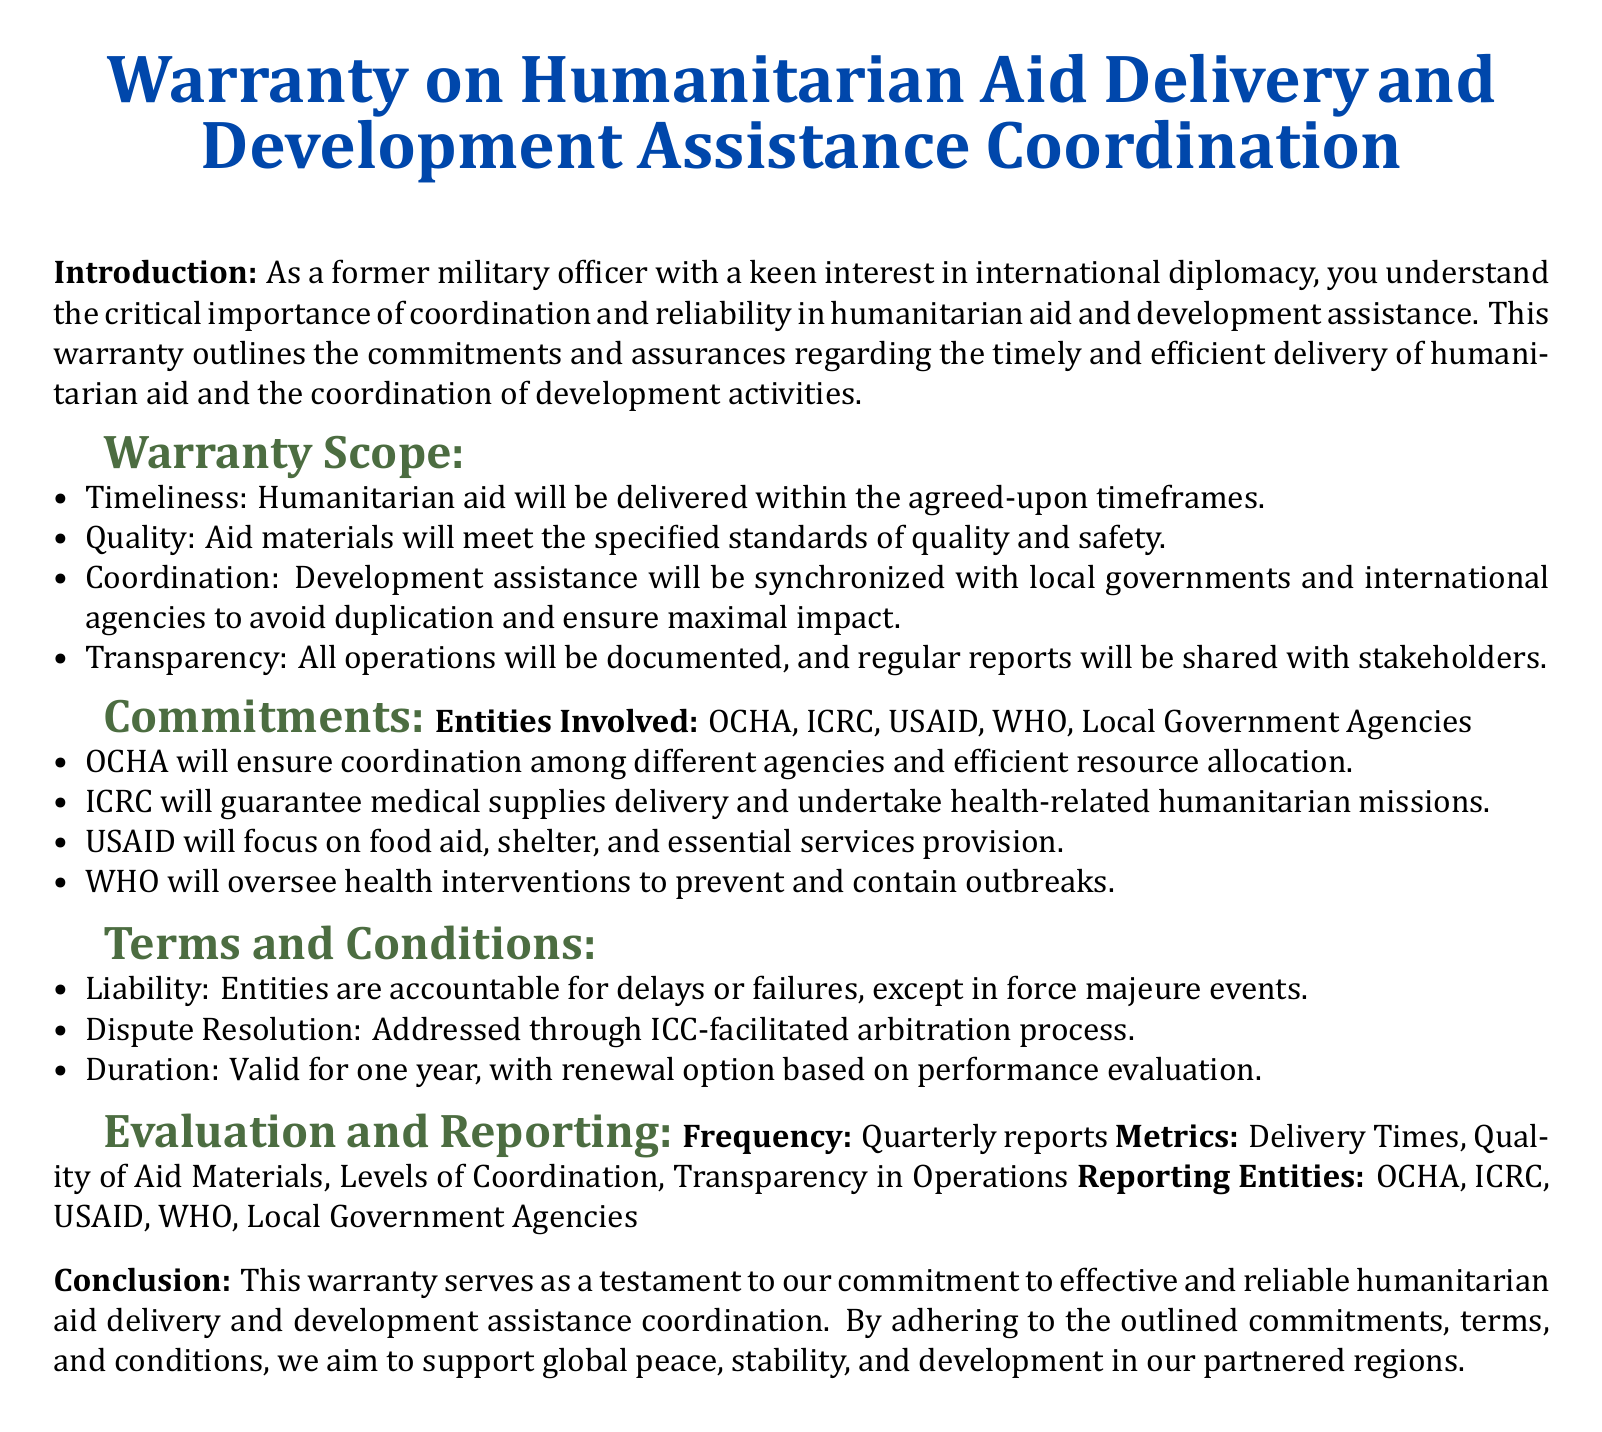What is the title of the document? The title is prominently displayed at the top of the document and states the subject matter.
Answer: Warranty on Humanitarian Aid Delivery and Development Assistance Coordination What organization guarantees medical supplies delivery? The organization responsible for medical supplies delivery is listed under the commitments section.
Answer: ICRC What is the liability condition stated in the document? The document specifies the accountability of entities for failures or delays in the liability section.
Answer: Exception in force majeure events How frequently are reports generated? The frequency of reports is mentioned under the evaluation section of the document.
Answer: Quarterly What agency focuses on food aid, shelter, and essential services? The agency designated for food aid and related services is specified in the commitments section.
Answer: USAID What is the duration of the warranty? The duration of the warranty is mentioned in the terms and conditions section of the document.
Answer: One year Which organization will ensure coordination among different agencies? The agency responsible for coordination efforts is highlighted in the commitments section.
Answer: OCHA What types of metrics are used for evaluation? The types of metrics for evaluation are outlined in the evaluation section of the document.
Answer: Delivery Times, Quality of Aid Materials, Levels of Coordination, Transparency in Operations 